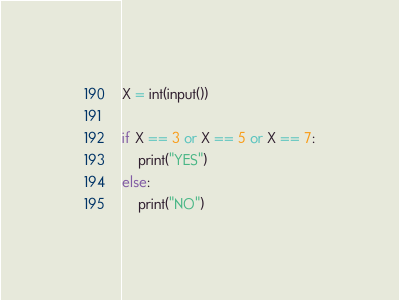Convert code to text. <code><loc_0><loc_0><loc_500><loc_500><_Python_>X = int(input())

if X == 3 or X == 5 or X == 7:
	print("YES")
else:
	print("NO")</code> 